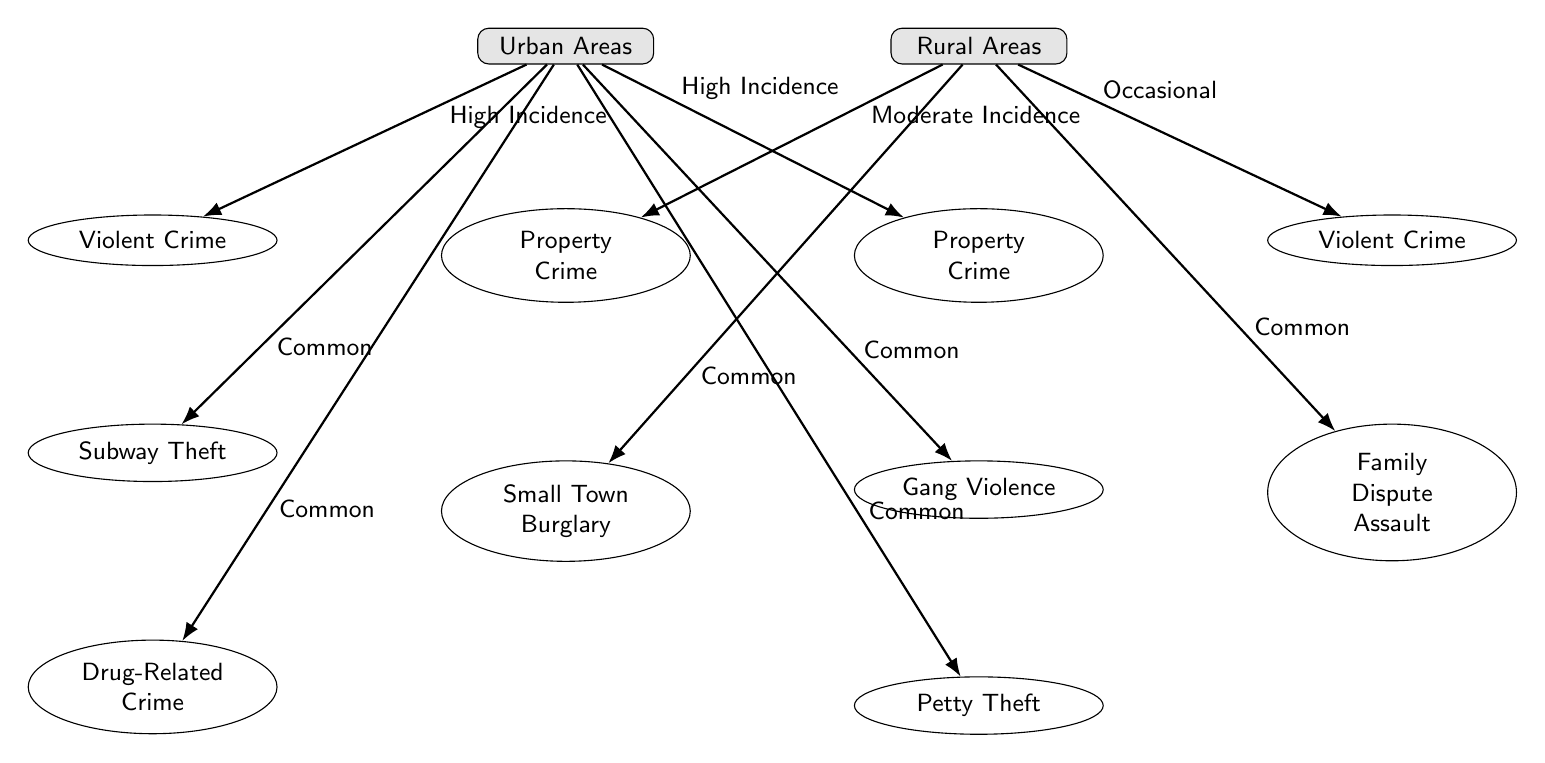What are the two main crime categories listed for urban areas? The diagram identifies "Violent Crime" and "Property Crime" as the two main categories available beneath the "Urban Areas" node. These are the primary types of crimes indicated for urban settings.
Answer: Violent Crime, Property Crime What type of crime has a high incidence in urban areas? The diagram specifies that both "Violent Crime" and "Property Crime" have a "High Incidence" in urban areas, indicating these are more prevalent compared to other types.
Answer: Violent Crime, Property Crime How many types of crimes are listed under rural areas? The diagram shows a total of two distinct types of crimes listed directly under the "Rural Areas" node, specifically "Property Crime" and "Violent Crime."
Answer: 2 What type of crime is often associated with family disputes in rural areas? According to the diagram, "Family Dispute Assault" is the crime type that relates specifically to rural areas and is mentioned as a form of violent crime.
Answer: Family Dispute Assault Which crime type has the label "Common" in urban areas? The diagram illustrates that "Subway Theft," "Gang Violence," "Drug-Related Crime," and "Petty Theft" are all labeled as "Common" in urban areas, indicating these occur with some regularity.
Answer: Subway Theft, Gang Violence, Drug-Related Crime, Petty Theft Which type of crime is common in both urban and rural areas? Based on the data presented in the diagram, "Property Crime" is common in both urban and rural settings, revealing its prevalence across different types of geographic locations.
Answer: Property Crime What crime is labeled as having a "Moderate Incidence" in rural areas? The diagram indicates that "Property Crime" in rural areas has a "Moderate Incidence," suggesting it does not occur as frequently as urban property crimes but is still significant.
Answer: Property Crime How is gang violence characterized in urban areas? The diagram conveys that "Gang Violence" is categorized as "Common" within urban areas, indicating that this type of crime occurs with some level of frequency.
Answer: Common What crime type has a "High Incidence" in urban areas but is not labeled as common? The crime types that are labeled as "High Incidence" in urban areas but not marked as "Common" are both "Violent Crime" and "Property Crime."
Answer: Violent Crime, Property Crime 